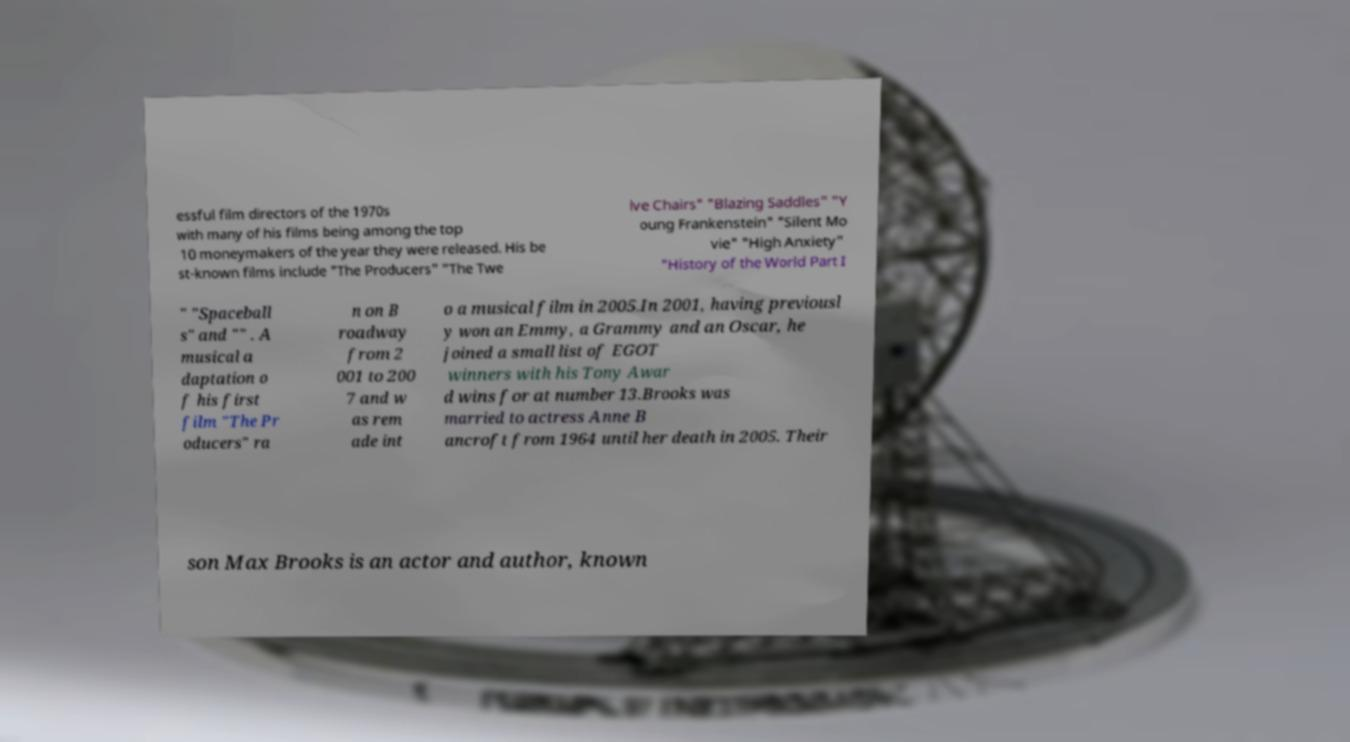For documentation purposes, I need the text within this image transcribed. Could you provide that? essful film directors of the 1970s with many of his films being among the top 10 moneymakers of the year they were released. His be st-known films include "The Producers" "The Twe lve Chairs" "Blazing Saddles" "Y oung Frankenstein" "Silent Mo vie" "High Anxiety" "History of the World Part I " "Spaceball s" and "" . A musical a daptation o f his first film "The Pr oducers" ra n on B roadway from 2 001 to 200 7 and w as rem ade int o a musical film in 2005.In 2001, having previousl y won an Emmy, a Grammy and an Oscar, he joined a small list of EGOT winners with his Tony Awar d wins for at number 13.Brooks was married to actress Anne B ancroft from 1964 until her death in 2005. Their son Max Brooks is an actor and author, known 